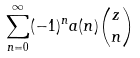Convert formula to latex. <formula><loc_0><loc_0><loc_500><loc_500>\sum _ { n = 0 } ^ { \infty } ( - 1 ) ^ { n } a ( n ) \binom { z } { n }</formula> 